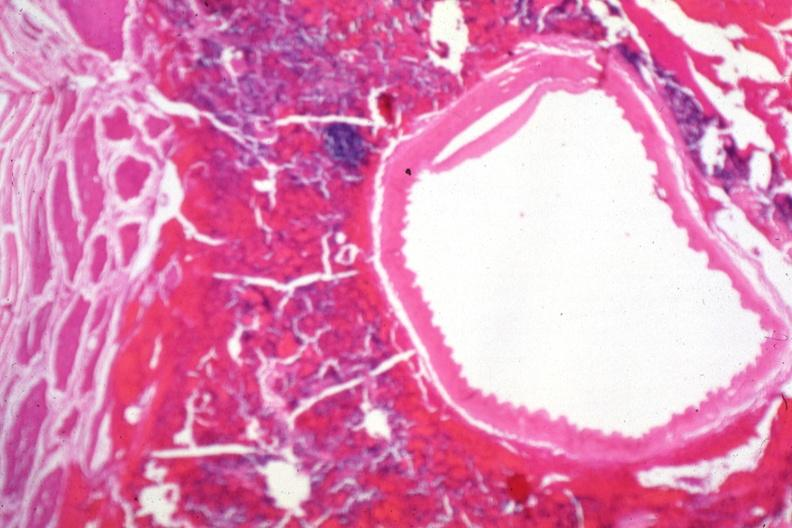does this image show carotid artery near sella with tumor cells in soft tissue?
Answer the question using a single word or phrase. Yes 